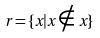Convert formula to latex. <formula><loc_0><loc_0><loc_500><loc_500>r = \{ x | x \notin x \}</formula> 